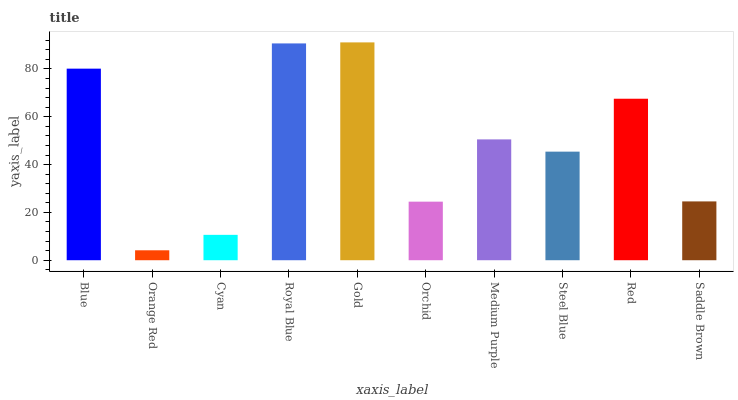Is Orange Red the minimum?
Answer yes or no. Yes. Is Gold the maximum?
Answer yes or no. Yes. Is Cyan the minimum?
Answer yes or no. No. Is Cyan the maximum?
Answer yes or no. No. Is Cyan greater than Orange Red?
Answer yes or no. Yes. Is Orange Red less than Cyan?
Answer yes or no. Yes. Is Orange Red greater than Cyan?
Answer yes or no. No. Is Cyan less than Orange Red?
Answer yes or no. No. Is Medium Purple the high median?
Answer yes or no. Yes. Is Steel Blue the low median?
Answer yes or no. Yes. Is Steel Blue the high median?
Answer yes or no. No. Is Red the low median?
Answer yes or no. No. 